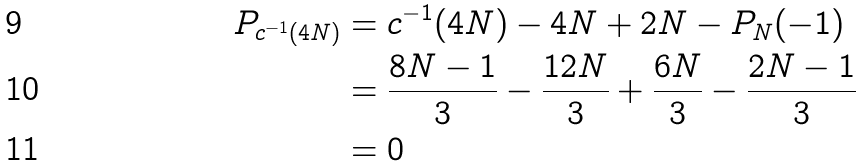Convert formula to latex. <formula><loc_0><loc_0><loc_500><loc_500>P _ { c ^ { - 1 } ( 4 N ) } & = c ^ { - 1 } ( 4 N ) - 4 N + 2 N - P _ { N } ( - 1 ) \\ & = \frac { 8 N - 1 } { 3 } - \frac { 1 2 N } { 3 } + \frac { 6 N } { 3 } - \frac { 2 N - 1 } { 3 } \\ & = 0</formula> 